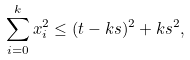<formula> <loc_0><loc_0><loc_500><loc_500>\sum _ { i = 0 } ^ { k } x _ { i } ^ { 2 } \leq ( t - k s ) ^ { 2 } + k s ^ { 2 } ,</formula> 